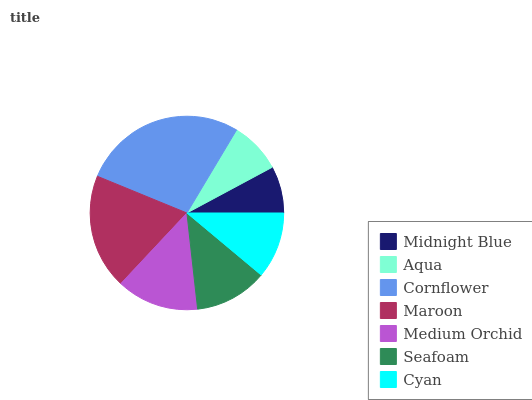Is Midnight Blue the minimum?
Answer yes or no. Yes. Is Cornflower the maximum?
Answer yes or no. Yes. Is Aqua the minimum?
Answer yes or no. No. Is Aqua the maximum?
Answer yes or no. No. Is Aqua greater than Midnight Blue?
Answer yes or no. Yes. Is Midnight Blue less than Aqua?
Answer yes or no. Yes. Is Midnight Blue greater than Aqua?
Answer yes or no. No. Is Aqua less than Midnight Blue?
Answer yes or no. No. Is Seafoam the high median?
Answer yes or no. Yes. Is Seafoam the low median?
Answer yes or no. Yes. Is Midnight Blue the high median?
Answer yes or no. No. Is Midnight Blue the low median?
Answer yes or no. No. 